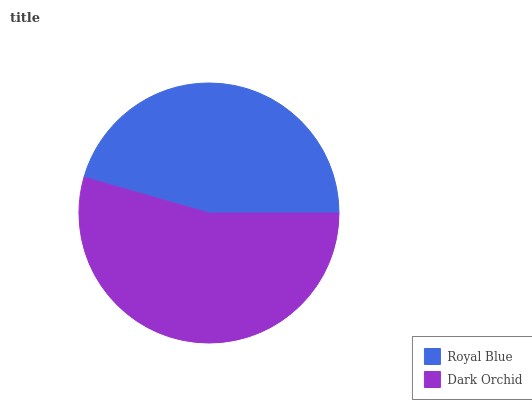Is Royal Blue the minimum?
Answer yes or no. Yes. Is Dark Orchid the maximum?
Answer yes or no. Yes. Is Dark Orchid the minimum?
Answer yes or no. No. Is Dark Orchid greater than Royal Blue?
Answer yes or no. Yes. Is Royal Blue less than Dark Orchid?
Answer yes or no. Yes. Is Royal Blue greater than Dark Orchid?
Answer yes or no. No. Is Dark Orchid less than Royal Blue?
Answer yes or no. No. Is Dark Orchid the high median?
Answer yes or no. Yes. Is Royal Blue the low median?
Answer yes or no. Yes. Is Royal Blue the high median?
Answer yes or no. No. Is Dark Orchid the low median?
Answer yes or no. No. 